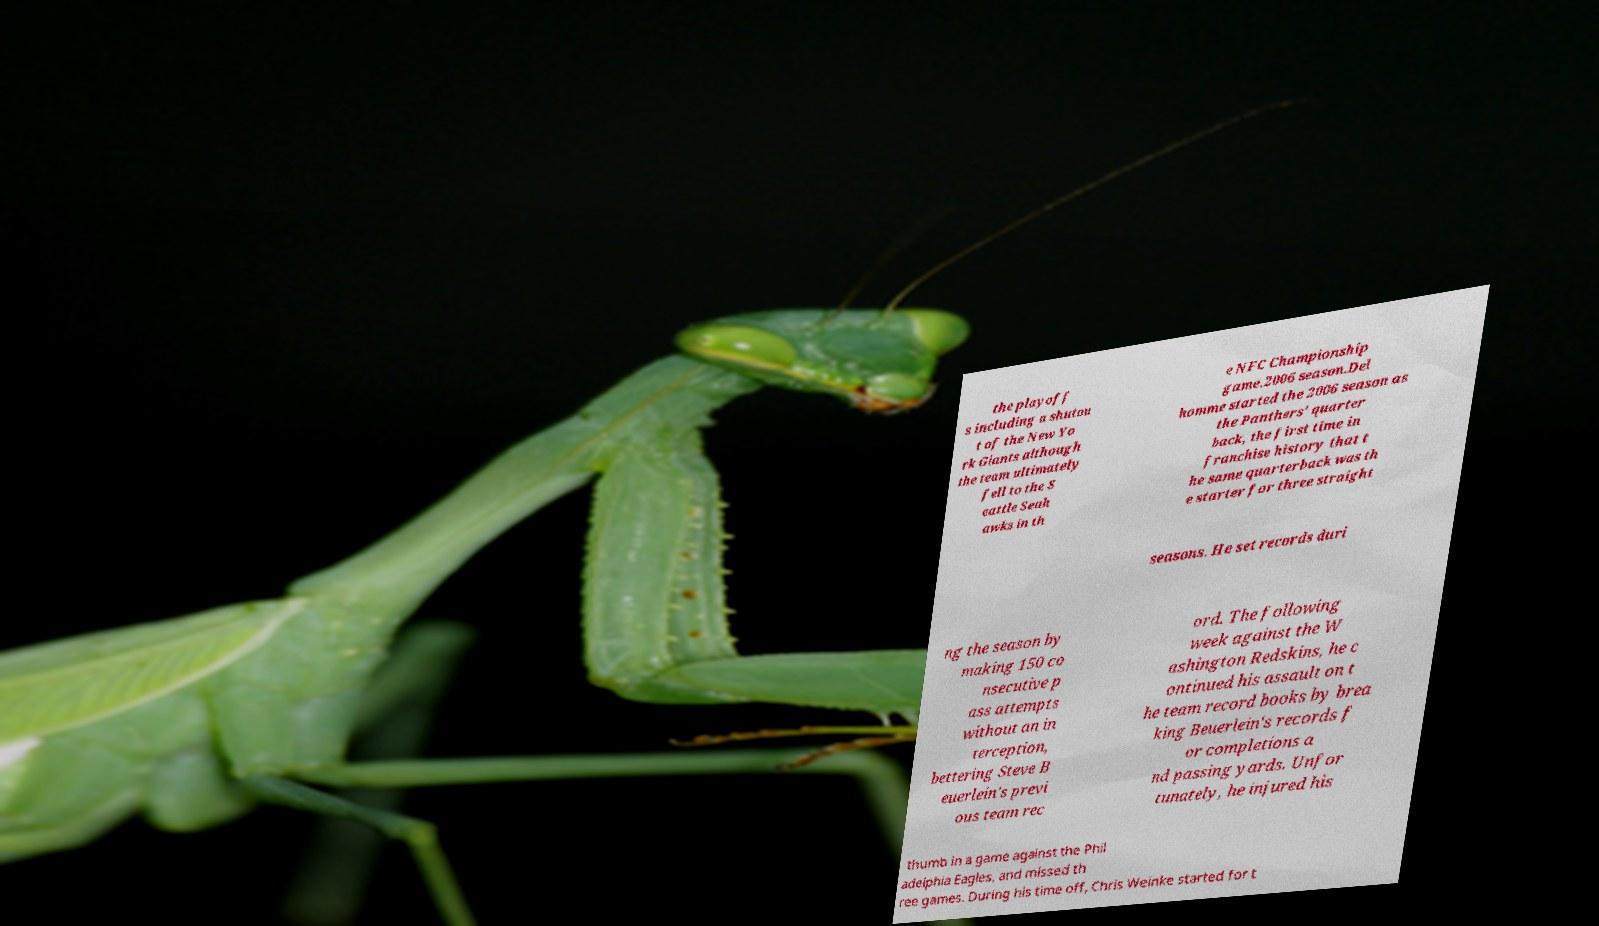There's text embedded in this image that I need extracted. Can you transcribe it verbatim? the playoff s including a shutou t of the New Yo rk Giants although the team ultimately fell to the S eattle Seah awks in th e NFC Championship game.2006 season.Del homme started the 2006 season as the Panthers' quarter back, the first time in franchise history that t he same quarterback was th e starter for three straight seasons. He set records duri ng the season by making 150 co nsecutive p ass attempts without an in terception, bettering Steve B euerlein's previ ous team rec ord. The following week against the W ashington Redskins, he c ontinued his assault on t he team record books by brea king Beuerlein's records f or completions a nd passing yards. Unfor tunately, he injured his thumb in a game against the Phil adelphia Eagles, and missed th ree games. During his time off, Chris Weinke started for t 